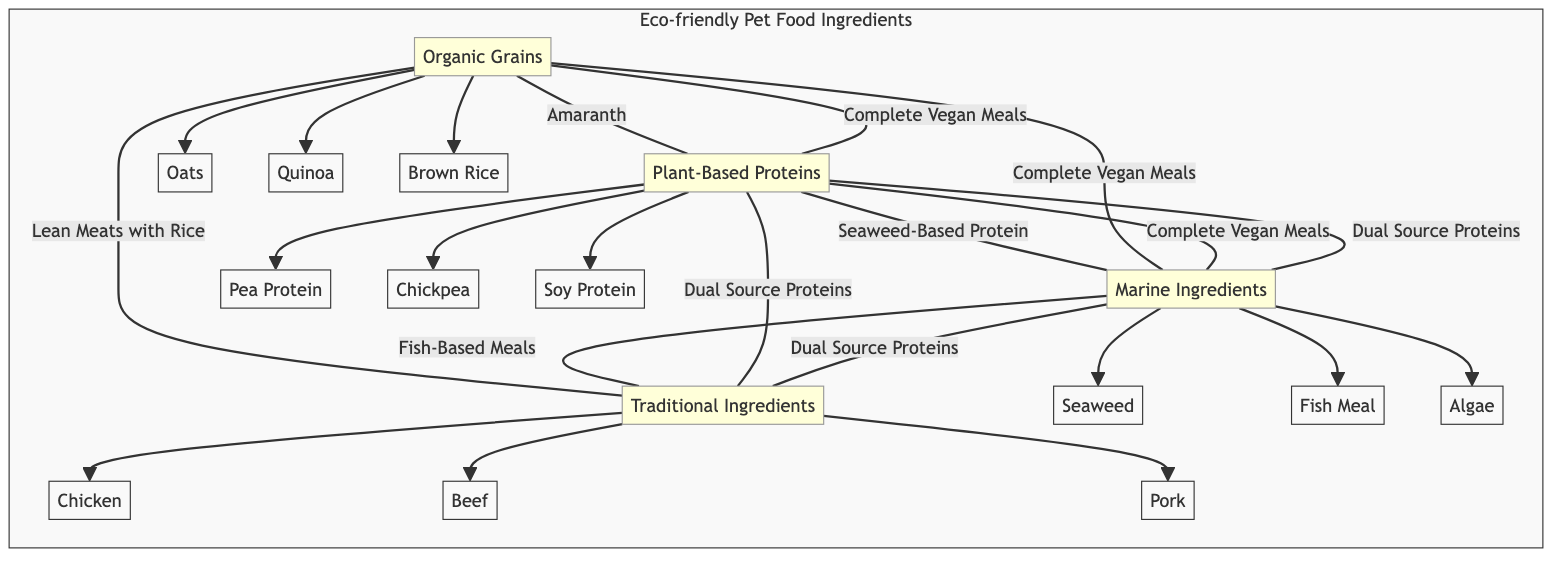What are the ingredients under Plant-Based Proteins? In the diagram, the node for Plant-Based Proteins connects to three ingredients: Pea Protein, Chickpea, and Soy Protein. These are directly listed as child nodes under the Plant-Based Proteins category.
Answer: Pea Protein, Chickpea, Soy Protein How many ingredients are listed under Marine Ingredients? The Marine Ingredients node has three child nodes connected to it, which are Seaweed, Fish Meal, and Algae. Therefore, there are a total of three specific ingredients under Marine Ingredients.
Answer: 3 What ingredient is common between Organic Grains and Plant-Based Proteins? The diagram shows a direct connection between Organic Grains and Plant-Based Proteins via the Complete Vegan Meals node, indicating that Complete Vegan Meals is a product associated with both categories.
Answer: Complete Vegan Meals What is the relationship between Marine Ingredients and Traditional Ingredients? The diagram indicates a connection between Marine Ingredients and Traditional Ingredients through the Dual Source Proteins node, meaning Dual Source Proteins can involve ingredients from both of these categories.
Answer: Dual Source Proteins How many total categories of ingredients are represented in the diagram? The diagram features four distinct categories: Organic Grains, Plant-Based Proteins, Marine Ingredients, and Traditional Ingredients. By counting these categories, we conclude there are four.
Answer: 4 Which ingredient connects both Traditional and Marine Ingredients? The link between Traditional Ingredients and Marine Ingredients is represented by the Fish-Based Meals node, indicating that Fish-Based Meals relates to both categories.
Answer: Fish-Based Meals What is the least represented category in terms of ingredient nodes? After reviewing the nodes, Traditional Ingredients has the least number of direct child nodes, with only three (Chicken, Beef, Pork) compared to the other categories.
Answer: Traditional Ingredients Which category has the most interconnected ingredients? By examining the connections, the Plant-Based Proteins category has multiple intersections with both Organic Grains and Marine Ingredients. This indicates higher interconnectivity through various overlapping ingredients.
Answer: Plant-Based Proteins Which ingredient appears under both Organic Grains and Marine Ingredients? The diagram shows that while the Complete Vegan Meals node appears under both Organic Grains and Plant-Based Proteins, there isn’t an ingredient specifically identified to appear under both Organic Grains and Marine Ingredients directly in the nodes listed. Therefore, the answer is none.
Answer: None 